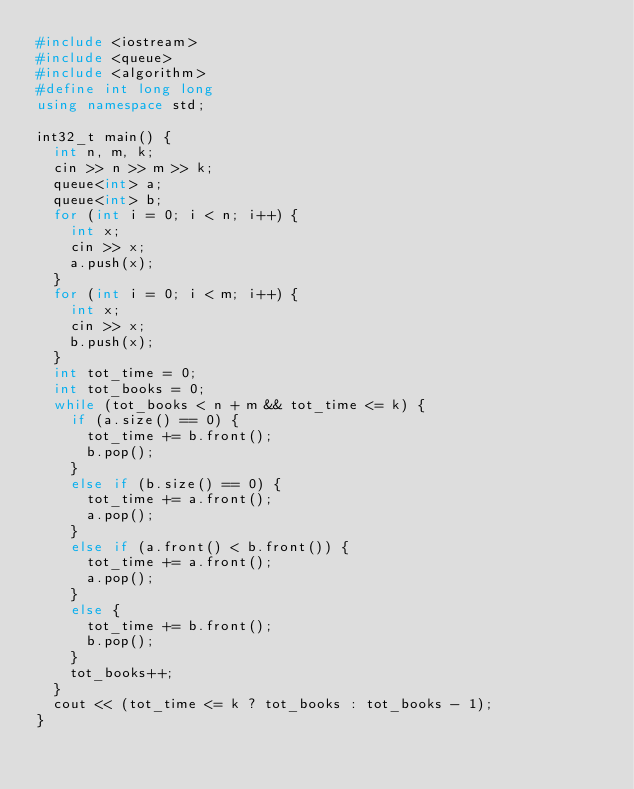<code> <loc_0><loc_0><loc_500><loc_500><_C++_>#include <iostream>
#include <queue>
#include <algorithm>
#define int long long
using namespace std;

int32_t main() {
	int n, m, k;
	cin >> n >> m >> k;
	queue<int> a;
	queue<int> b;
	for (int i = 0; i < n; i++) {
		int x;
		cin >> x;
		a.push(x);
	}
	for (int i = 0; i < m; i++) {
		int x;
		cin >> x;
		b.push(x);
	}
	int tot_time = 0;
	int tot_books = 0;
	while (tot_books < n + m && tot_time <= k) {
		if (a.size() == 0) {
			tot_time += b.front();
			b.pop();
		}
		else if (b.size() == 0) {
			tot_time += a.front();
			a.pop();
		}
		else if (a.front() < b.front()) {
			tot_time += a.front();
			a.pop();
		}
		else {
			tot_time += b.front();
			b.pop();
		}
		tot_books++;
	}
	cout << (tot_time <= k ? tot_books : tot_books - 1);
}</code> 